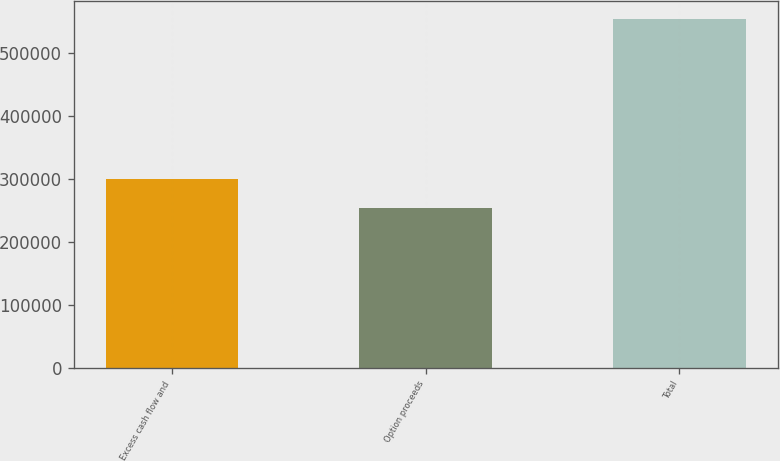Convert chart to OTSL. <chart><loc_0><loc_0><loc_500><loc_500><bar_chart><fcel>Excess cash flow and<fcel>Option proceeds<fcel>Total<nl><fcel>300134<fcel>254812<fcel>554946<nl></chart> 